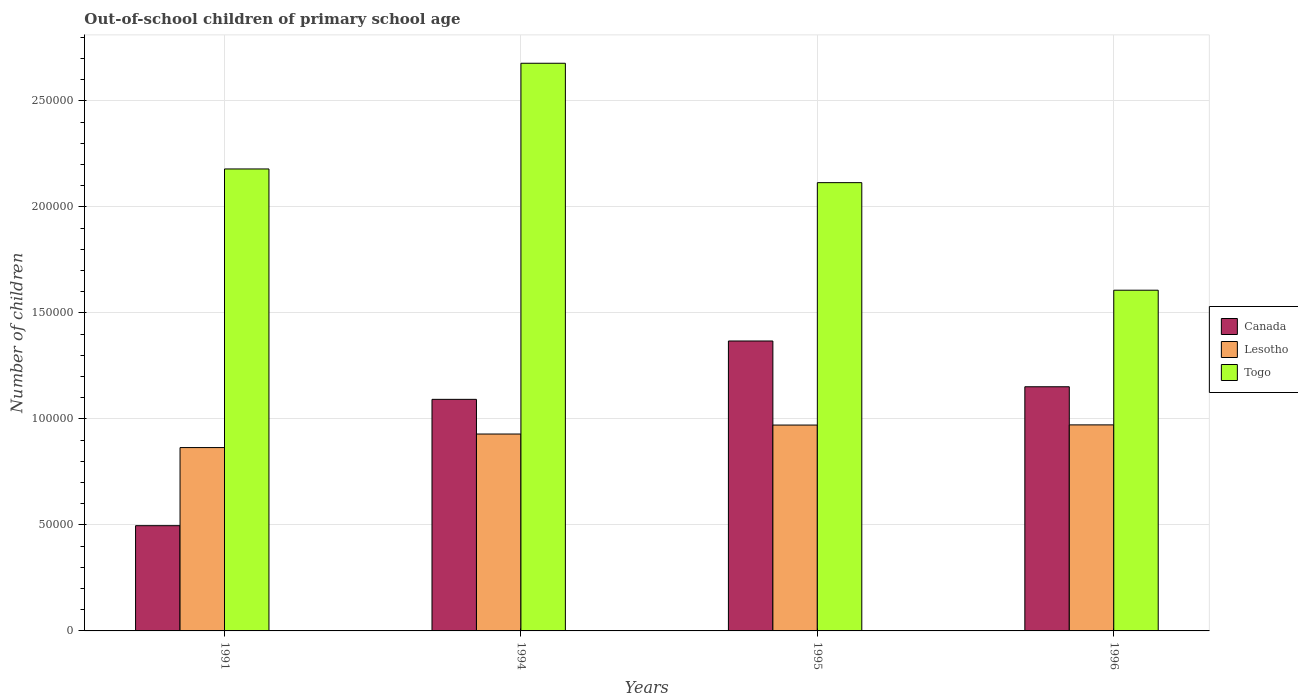How many groups of bars are there?
Your answer should be compact. 4. Are the number of bars on each tick of the X-axis equal?
Give a very brief answer. Yes. How many bars are there on the 4th tick from the right?
Your answer should be very brief. 3. What is the label of the 3rd group of bars from the left?
Give a very brief answer. 1995. In how many cases, is the number of bars for a given year not equal to the number of legend labels?
Your answer should be compact. 0. What is the number of out-of-school children in Togo in 1995?
Offer a very short reply. 2.11e+05. Across all years, what is the maximum number of out-of-school children in Togo?
Provide a short and direct response. 2.68e+05. Across all years, what is the minimum number of out-of-school children in Lesotho?
Make the answer very short. 8.65e+04. In which year was the number of out-of-school children in Togo minimum?
Make the answer very short. 1996. What is the total number of out-of-school children in Canada in the graph?
Ensure brevity in your answer.  4.11e+05. What is the difference between the number of out-of-school children in Lesotho in 1991 and that in 1995?
Your response must be concise. -1.06e+04. What is the difference between the number of out-of-school children in Lesotho in 1996 and the number of out-of-school children in Togo in 1994?
Your answer should be compact. -1.71e+05. What is the average number of out-of-school children in Canada per year?
Ensure brevity in your answer.  1.03e+05. In the year 1991, what is the difference between the number of out-of-school children in Canada and number of out-of-school children in Togo?
Make the answer very short. -1.68e+05. In how many years, is the number of out-of-school children in Lesotho greater than 270000?
Offer a terse response. 0. What is the ratio of the number of out-of-school children in Togo in 1994 to that in 1996?
Give a very brief answer. 1.67. What is the difference between the highest and the second highest number of out-of-school children in Canada?
Provide a succinct answer. 2.16e+04. What is the difference between the highest and the lowest number of out-of-school children in Togo?
Provide a succinct answer. 1.07e+05. Is the sum of the number of out-of-school children in Lesotho in 1991 and 1994 greater than the maximum number of out-of-school children in Canada across all years?
Offer a very short reply. Yes. What does the 3rd bar from the right in 1994 represents?
Ensure brevity in your answer.  Canada. How many years are there in the graph?
Give a very brief answer. 4. Does the graph contain any zero values?
Offer a terse response. No. Does the graph contain grids?
Give a very brief answer. Yes. How many legend labels are there?
Offer a very short reply. 3. What is the title of the graph?
Provide a short and direct response. Out-of-school children of primary school age. Does "Iran" appear as one of the legend labels in the graph?
Give a very brief answer. No. What is the label or title of the Y-axis?
Your answer should be compact. Number of children. What is the Number of children in Canada in 1991?
Ensure brevity in your answer.  4.96e+04. What is the Number of children in Lesotho in 1991?
Provide a succinct answer. 8.65e+04. What is the Number of children of Togo in 1991?
Your response must be concise. 2.18e+05. What is the Number of children in Canada in 1994?
Ensure brevity in your answer.  1.09e+05. What is the Number of children in Lesotho in 1994?
Your response must be concise. 9.29e+04. What is the Number of children in Togo in 1994?
Provide a short and direct response. 2.68e+05. What is the Number of children of Canada in 1995?
Keep it short and to the point. 1.37e+05. What is the Number of children in Lesotho in 1995?
Provide a short and direct response. 9.71e+04. What is the Number of children in Togo in 1995?
Your answer should be very brief. 2.11e+05. What is the Number of children of Canada in 1996?
Give a very brief answer. 1.15e+05. What is the Number of children of Lesotho in 1996?
Make the answer very short. 9.72e+04. What is the Number of children of Togo in 1996?
Ensure brevity in your answer.  1.61e+05. Across all years, what is the maximum Number of children in Canada?
Offer a very short reply. 1.37e+05. Across all years, what is the maximum Number of children of Lesotho?
Your answer should be compact. 9.72e+04. Across all years, what is the maximum Number of children in Togo?
Offer a terse response. 2.68e+05. Across all years, what is the minimum Number of children in Canada?
Make the answer very short. 4.96e+04. Across all years, what is the minimum Number of children of Lesotho?
Give a very brief answer. 8.65e+04. Across all years, what is the minimum Number of children in Togo?
Ensure brevity in your answer.  1.61e+05. What is the total Number of children in Canada in the graph?
Keep it short and to the point. 4.11e+05. What is the total Number of children of Lesotho in the graph?
Provide a succinct answer. 3.74e+05. What is the total Number of children in Togo in the graph?
Provide a succinct answer. 8.58e+05. What is the difference between the Number of children in Canada in 1991 and that in 1994?
Provide a succinct answer. -5.96e+04. What is the difference between the Number of children in Lesotho in 1991 and that in 1994?
Ensure brevity in your answer.  -6393. What is the difference between the Number of children of Togo in 1991 and that in 1994?
Your answer should be compact. -4.99e+04. What is the difference between the Number of children in Canada in 1991 and that in 1995?
Your response must be concise. -8.71e+04. What is the difference between the Number of children in Lesotho in 1991 and that in 1995?
Your response must be concise. -1.06e+04. What is the difference between the Number of children of Togo in 1991 and that in 1995?
Provide a short and direct response. 6458. What is the difference between the Number of children in Canada in 1991 and that in 1996?
Your answer should be compact. -6.55e+04. What is the difference between the Number of children of Lesotho in 1991 and that in 1996?
Offer a very short reply. -1.07e+04. What is the difference between the Number of children in Togo in 1991 and that in 1996?
Your response must be concise. 5.72e+04. What is the difference between the Number of children in Canada in 1994 and that in 1995?
Provide a short and direct response. -2.75e+04. What is the difference between the Number of children of Lesotho in 1994 and that in 1995?
Your answer should be compact. -4228. What is the difference between the Number of children of Togo in 1994 and that in 1995?
Give a very brief answer. 5.63e+04. What is the difference between the Number of children in Canada in 1994 and that in 1996?
Your answer should be very brief. -5942. What is the difference between the Number of children of Lesotho in 1994 and that in 1996?
Offer a very short reply. -4310. What is the difference between the Number of children in Togo in 1994 and that in 1996?
Keep it short and to the point. 1.07e+05. What is the difference between the Number of children of Canada in 1995 and that in 1996?
Keep it short and to the point. 2.16e+04. What is the difference between the Number of children of Lesotho in 1995 and that in 1996?
Provide a succinct answer. -82. What is the difference between the Number of children of Togo in 1995 and that in 1996?
Provide a short and direct response. 5.07e+04. What is the difference between the Number of children in Canada in 1991 and the Number of children in Lesotho in 1994?
Your answer should be compact. -4.32e+04. What is the difference between the Number of children of Canada in 1991 and the Number of children of Togo in 1994?
Your response must be concise. -2.18e+05. What is the difference between the Number of children of Lesotho in 1991 and the Number of children of Togo in 1994?
Ensure brevity in your answer.  -1.81e+05. What is the difference between the Number of children of Canada in 1991 and the Number of children of Lesotho in 1995?
Your answer should be very brief. -4.75e+04. What is the difference between the Number of children in Canada in 1991 and the Number of children in Togo in 1995?
Provide a succinct answer. -1.62e+05. What is the difference between the Number of children in Lesotho in 1991 and the Number of children in Togo in 1995?
Provide a short and direct response. -1.25e+05. What is the difference between the Number of children in Canada in 1991 and the Number of children in Lesotho in 1996?
Your answer should be very brief. -4.75e+04. What is the difference between the Number of children of Canada in 1991 and the Number of children of Togo in 1996?
Make the answer very short. -1.11e+05. What is the difference between the Number of children in Lesotho in 1991 and the Number of children in Togo in 1996?
Provide a short and direct response. -7.42e+04. What is the difference between the Number of children of Canada in 1994 and the Number of children of Lesotho in 1995?
Provide a short and direct response. 1.21e+04. What is the difference between the Number of children of Canada in 1994 and the Number of children of Togo in 1995?
Provide a succinct answer. -1.02e+05. What is the difference between the Number of children in Lesotho in 1994 and the Number of children in Togo in 1995?
Your answer should be compact. -1.19e+05. What is the difference between the Number of children in Canada in 1994 and the Number of children in Lesotho in 1996?
Provide a short and direct response. 1.20e+04. What is the difference between the Number of children in Canada in 1994 and the Number of children in Togo in 1996?
Offer a terse response. -5.15e+04. What is the difference between the Number of children of Lesotho in 1994 and the Number of children of Togo in 1996?
Your response must be concise. -6.78e+04. What is the difference between the Number of children of Canada in 1995 and the Number of children of Lesotho in 1996?
Give a very brief answer. 3.96e+04. What is the difference between the Number of children of Canada in 1995 and the Number of children of Togo in 1996?
Make the answer very short. -2.40e+04. What is the difference between the Number of children of Lesotho in 1995 and the Number of children of Togo in 1996?
Provide a succinct answer. -6.36e+04. What is the average Number of children of Canada per year?
Your answer should be compact. 1.03e+05. What is the average Number of children in Lesotho per year?
Your answer should be compact. 9.34e+04. What is the average Number of children in Togo per year?
Your answer should be compact. 2.14e+05. In the year 1991, what is the difference between the Number of children of Canada and Number of children of Lesotho?
Offer a terse response. -3.68e+04. In the year 1991, what is the difference between the Number of children of Canada and Number of children of Togo?
Provide a succinct answer. -1.68e+05. In the year 1991, what is the difference between the Number of children in Lesotho and Number of children in Togo?
Your answer should be very brief. -1.31e+05. In the year 1994, what is the difference between the Number of children in Canada and Number of children in Lesotho?
Offer a terse response. 1.64e+04. In the year 1994, what is the difference between the Number of children in Canada and Number of children in Togo?
Provide a short and direct response. -1.59e+05. In the year 1994, what is the difference between the Number of children of Lesotho and Number of children of Togo?
Offer a very short reply. -1.75e+05. In the year 1995, what is the difference between the Number of children of Canada and Number of children of Lesotho?
Your response must be concise. 3.97e+04. In the year 1995, what is the difference between the Number of children of Canada and Number of children of Togo?
Give a very brief answer. -7.47e+04. In the year 1995, what is the difference between the Number of children of Lesotho and Number of children of Togo?
Keep it short and to the point. -1.14e+05. In the year 1996, what is the difference between the Number of children in Canada and Number of children in Lesotho?
Make the answer very short. 1.80e+04. In the year 1996, what is the difference between the Number of children in Canada and Number of children in Togo?
Your answer should be very brief. -4.55e+04. In the year 1996, what is the difference between the Number of children of Lesotho and Number of children of Togo?
Ensure brevity in your answer.  -6.35e+04. What is the ratio of the Number of children of Canada in 1991 to that in 1994?
Make the answer very short. 0.45. What is the ratio of the Number of children of Lesotho in 1991 to that in 1994?
Provide a short and direct response. 0.93. What is the ratio of the Number of children of Togo in 1991 to that in 1994?
Your answer should be compact. 0.81. What is the ratio of the Number of children of Canada in 1991 to that in 1995?
Provide a succinct answer. 0.36. What is the ratio of the Number of children in Lesotho in 1991 to that in 1995?
Provide a succinct answer. 0.89. What is the ratio of the Number of children in Togo in 1991 to that in 1995?
Give a very brief answer. 1.03. What is the ratio of the Number of children in Canada in 1991 to that in 1996?
Ensure brevity in your answer.  0.43. What is the ratio of the Number of children in Lesotho in 1991 to that in 1996?
Offer a very short reply. 0.89. What is the ratio of the Number of children in Togo in 1991 to that in 1996?
Keep it short and to the point. 1.36. What is the ratio of the Number of children of Canada in 1994 to that in 1995?
Give a very brief answer. 0.8. What is the ratio of the Number of children of Lesotho in 1994 to that in 1995?
Offer a terse response. 0.96. What is the ratio of the Number of children in Togo in 1994 to that in 1995?
Make the answer very short. 1.27. What is the ratio of the Number of children in Canada in 1994 to that in 1996?
Give a very brief answer. 0.95. What is the ratio of the Number of children in Lesotho in 1994 to that in 1996?
Provide a succinct answer. 0.96. What is the ratio of the Number of children of Togo in 1994 to that in 1996?
Offer a very short reply. 1.67. What is the ratio of the Number of children of Canada in 1995 to that in 1996?
Ensure brevity in your answer.  1.19. What is the ratio of the Number of children of Togo in 1995 to that in 1996?
Provide a succinct answer. 1.32. What is the difference between the highest and the second highest Number of children of Canada?
Ensure brevity in your answer.  2.16e+04. What is the difference between the highest and the second highest Number of children in Togo?
Offer a very short reply. 4.99e+04. What is the difference between the highest and the lowest Number of children in Canada?
Your answer should be very brief. 8.71e+04. What is the difference between the highest and the lowest Number of children of Lesotho?
Offer a terse response. 1.07e+04. What is the difference between the highest and the lowest Number of children in Togo?
Make the answer very short. 1.07e+05. 